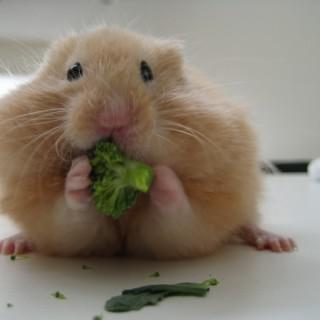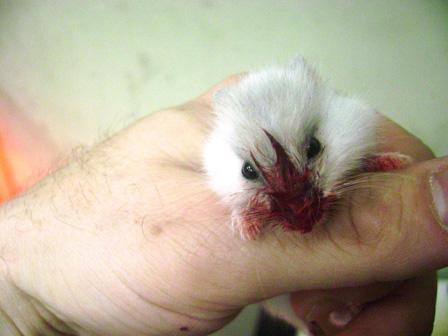The first image is the image on the left, the second image is the image on the right. Examine the images to the left and right. Is the description "Some of the hamsters are asleep." accurate? Answer yes or no. No. The first image is the image on the left, the second image is the image on the right. Analyze the images presented: Is the assertion "The left image shows two hamsters sleeping side-by-side with their eyes shut and paws facing upward." valid? Answer yes or no. No. 